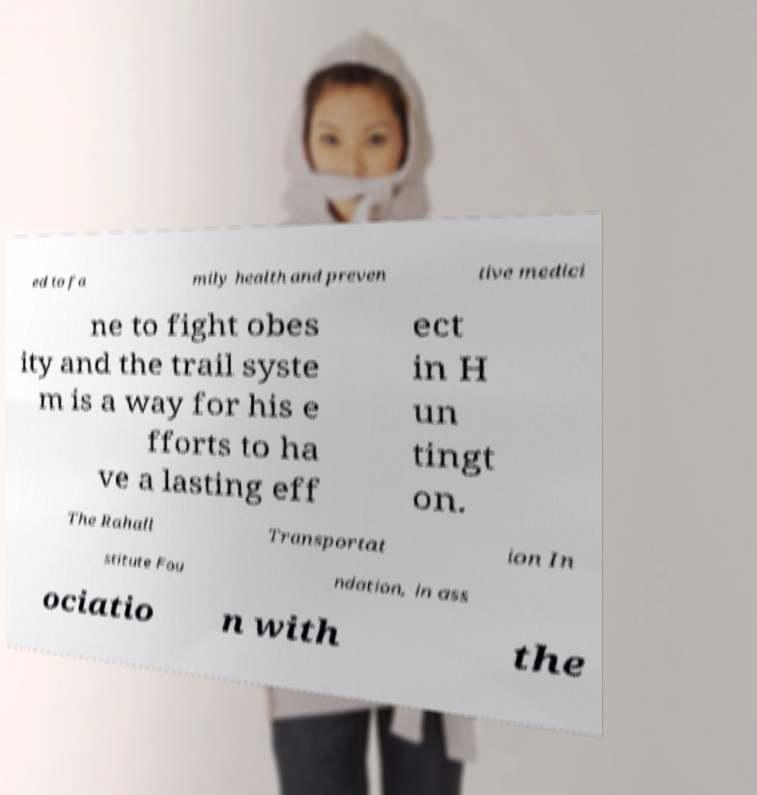Could you extract and type out the text from this image? ed to fa mily health and preven tive medici ne to fight obes ity and the trail syste m is a way for his e fforts to ha ve a lasting eff ect in H un tingt on. The Rahall Transportat ion In stitute Fou ndation, in ass ociatio n with the 